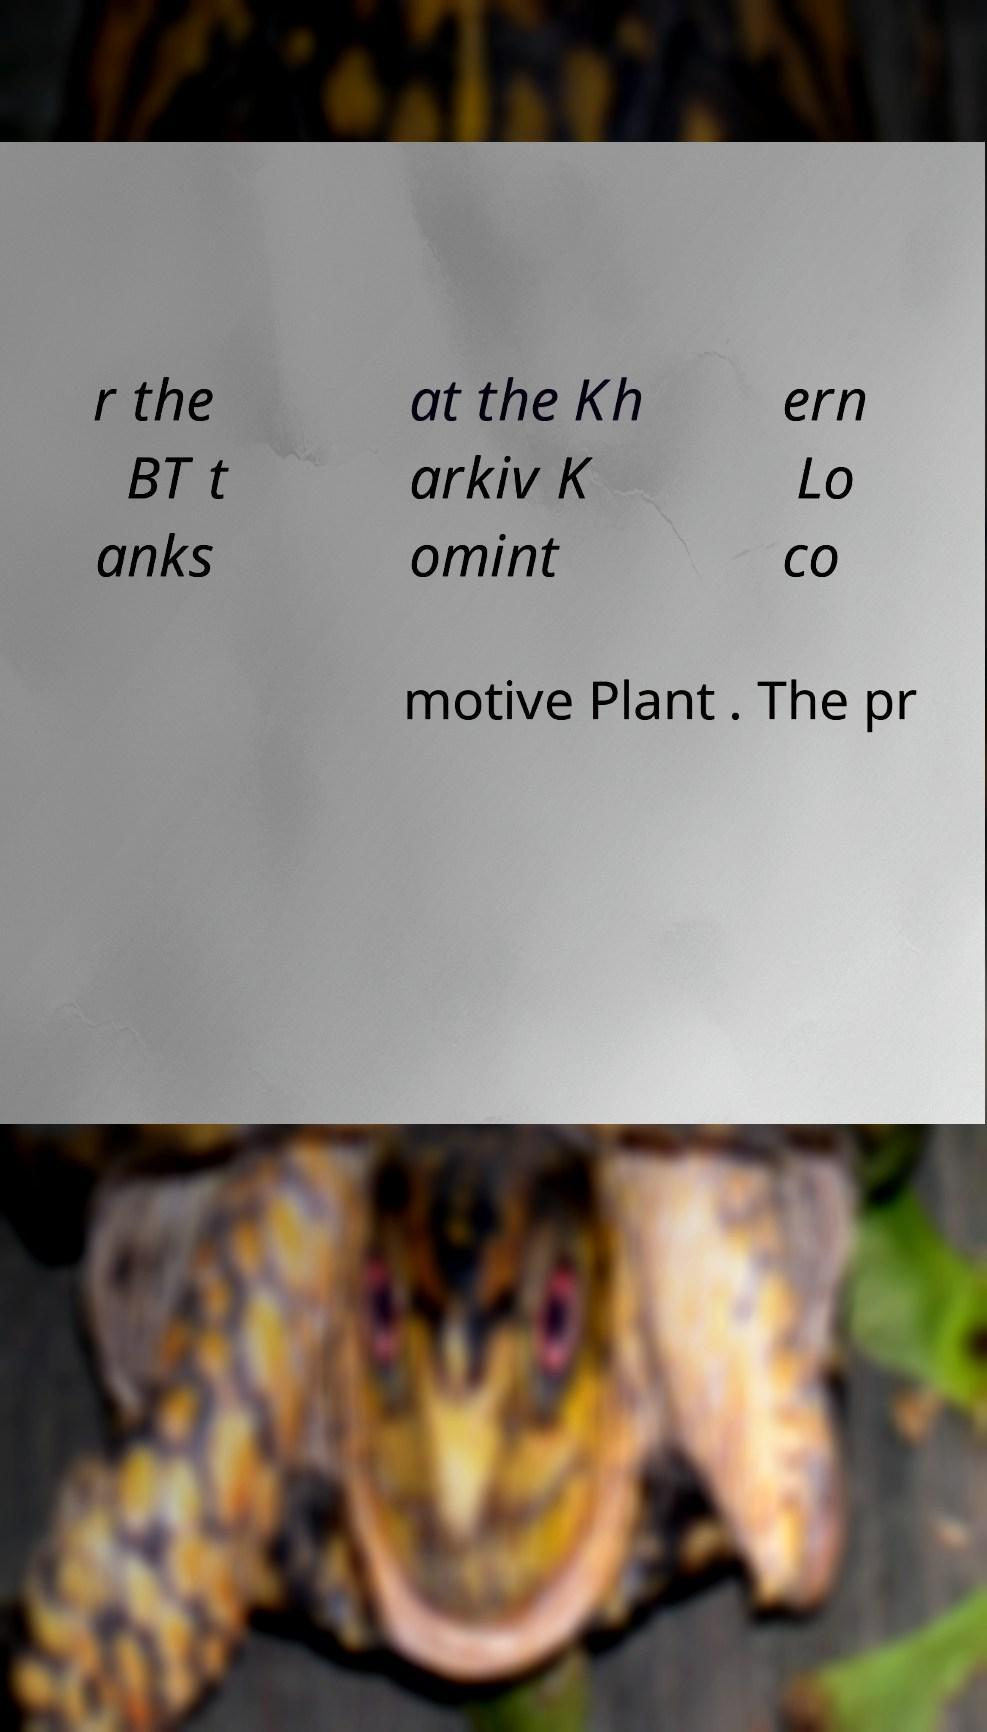Can you read and provide the text displayed in the image?This photo seems to have some interesting text. Can you extract and type it out for me? r the BT t anks at the Kh arkiv K omint ern Lo co motive Plant . The pr 